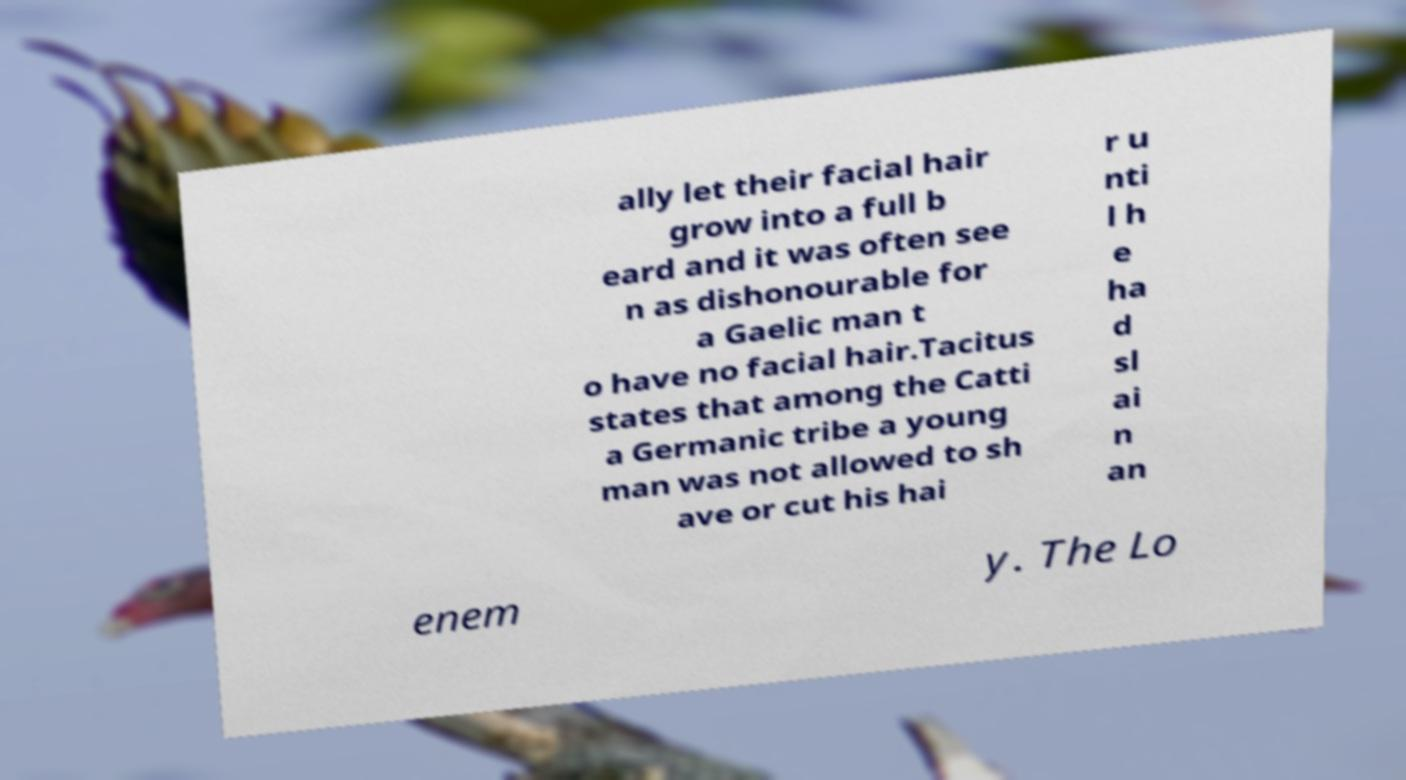I need the written content from this picture converted into text. Can you do that? ally let their facial hair grow into a full b eard and it was often see n as dishonourable for a Gaelic man t o have no facial hair.Tacitus states that among the Catti a Germanic tribe a young man was not allowed to sh ave or cut his hai r u nti l h e ha d sl ai n an enem y. The Lo 